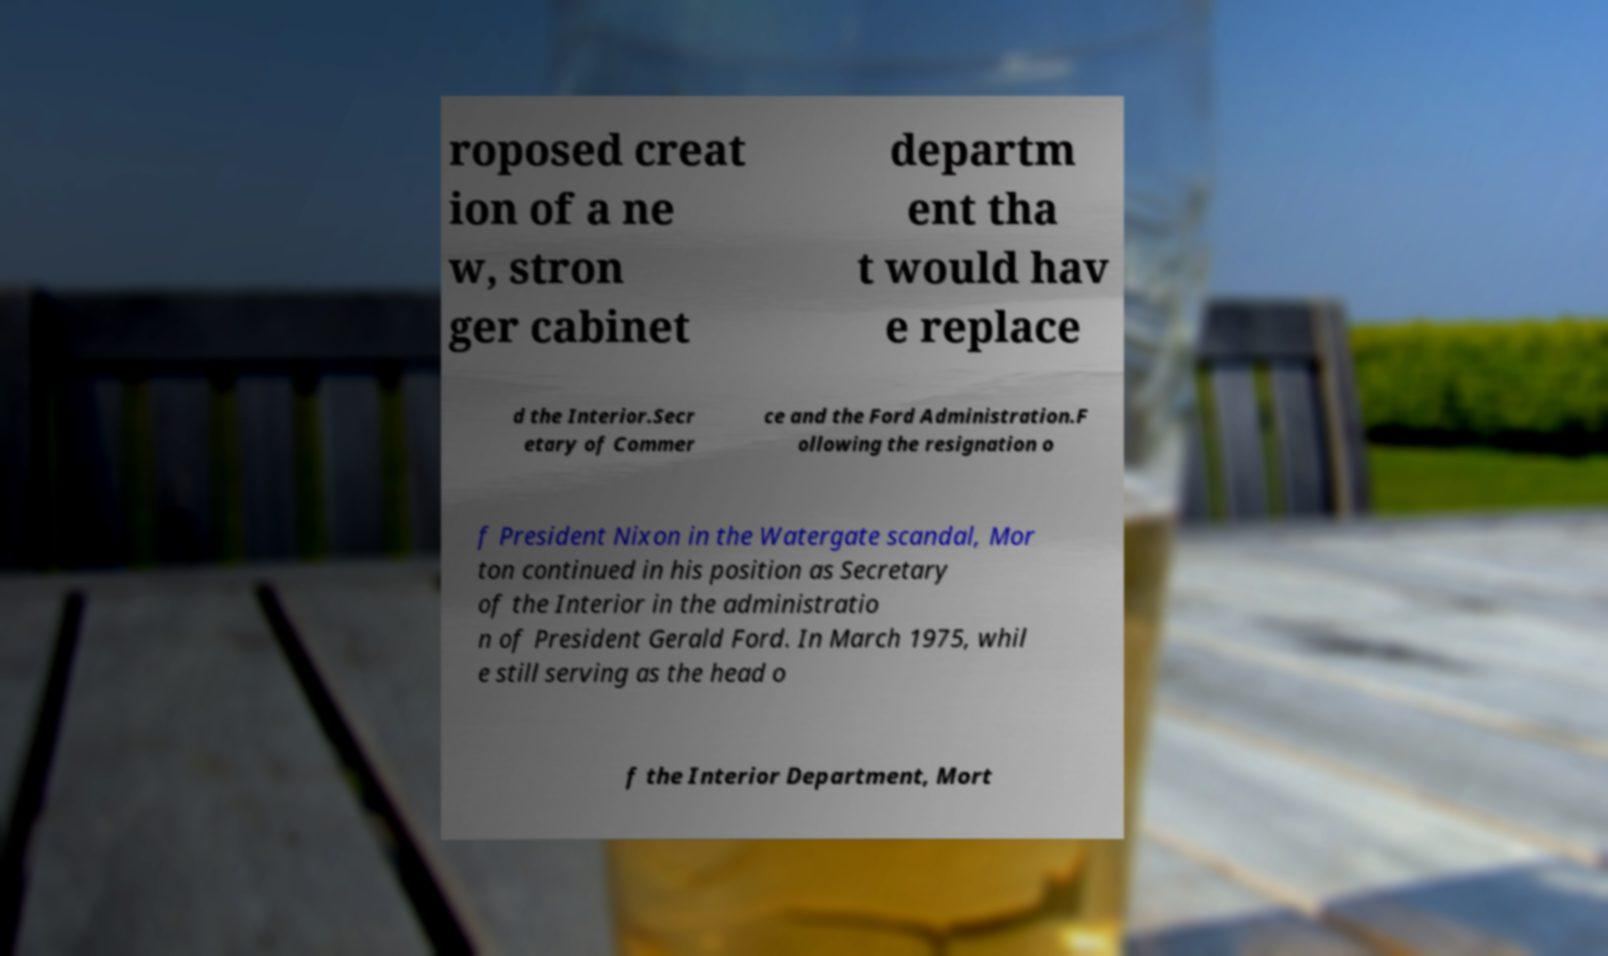There's text embedded in this image that I need extracted. Can you transcribe it verbatim? roposed creat ion of a ne w, stron ger cabinet departm ent tha t would hav e replace d the Interior.Secr etary of Commer ce and the Ford Administration.F ollowing the resignation o f President Nixon in the Watergate scandal, Mor ton continued in his position as Secretary of the Interior in the administratio n of President Gerald Ford. In March 1975, whil e still serving as the head o f the Interior Department, Mort 